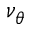<formula> <loc_0><loc_0><loc_500><loc_500>\nu _ { \theta }</formula> 